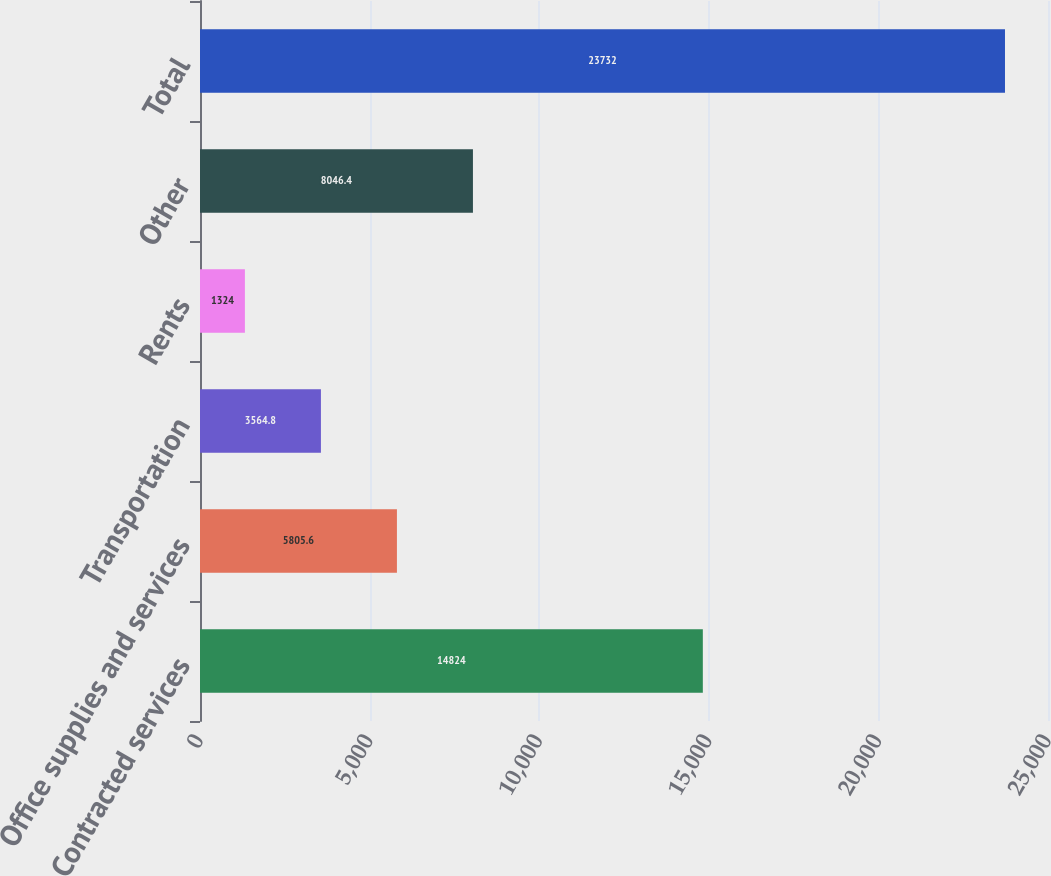Convert chart. <chart><loc_0><loc_0><loc_500><loc_500><bar_chart><fcel>Contracted services<fcel>Office supplies and services<fcel>Transportation<fcel>Rents<fcel>Other<fcel>Total<nl><fcel>14824<fcel>5805.6<fcel>3564.8<fcel>1324<fcel>8046.4<fcel>23732<nl></chart> 